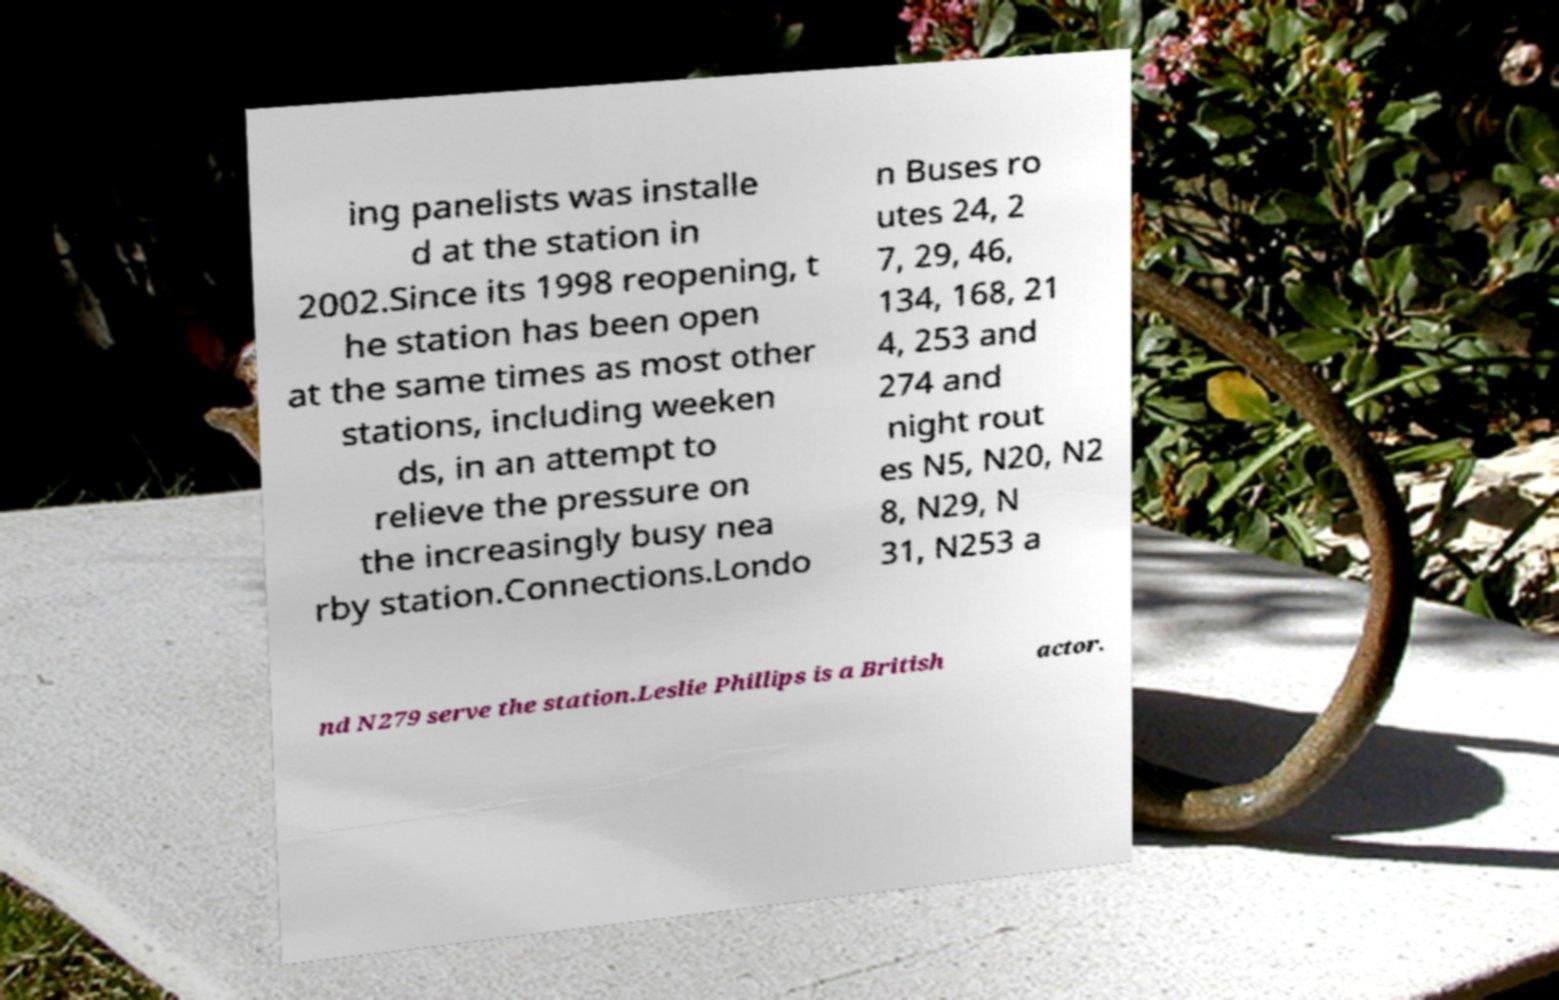I need the written content from this picture converted into text. Can you do that? ing panelists was installe d at the station in 2002.Since its 1998 reopening, t he station has been open at the same times as most other stations, including weeken ds, in an attempt to relieve the pressure on the increasingly busy nea rby station.Connections.Londo n Buses ro utes 24, 2 7, 29, 46, 134, 168, 21 4, 253 and 274 and night rout es N5, N20, N2 8, N29, N 31, N253 a nd N279 serve the station.Leslie Phillips is a British actor. 